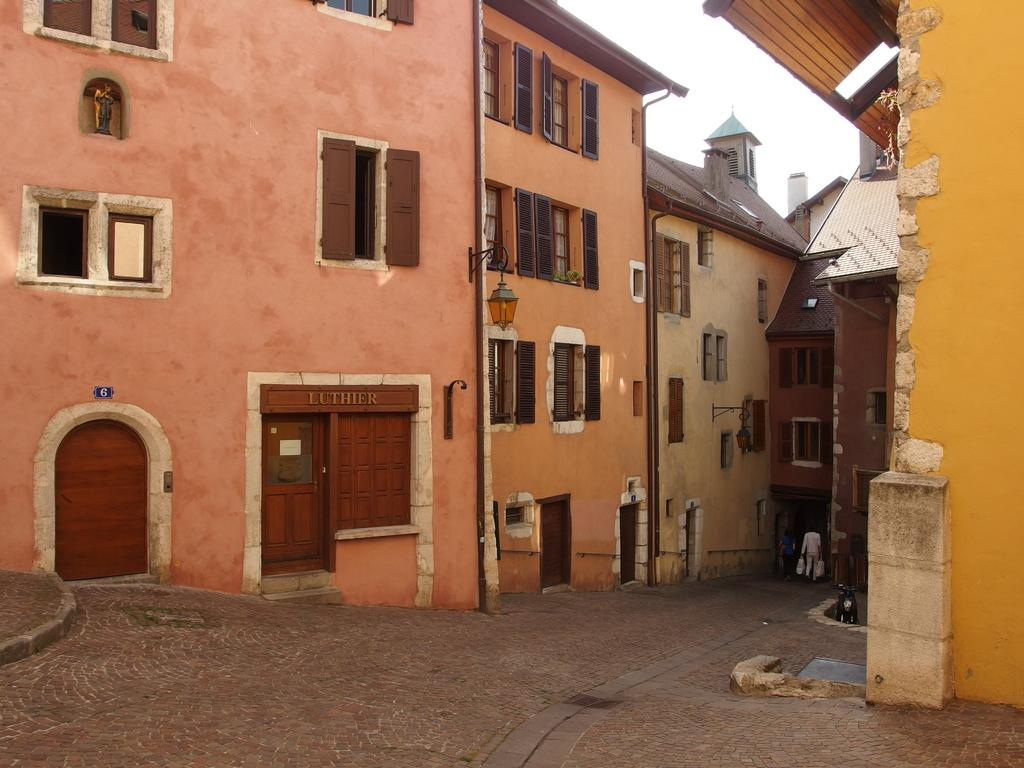What type of structures can be seen in the image? There are buildings in the image. What features can be observed on the buildings? There are windows and doors visible on the buildings. What mode of transportation is present in the image? There is a vehicle in the image. Who or what is on the road in the image? There are two persons on the road in the image. What part of the natural environment is visible in the image? The sky is visible in the image. Can you make an assumption about the time of day based on the image? The image might have been taken during the day, as there is no indication of darkness or artificial lighting. What type of plot is being developed by the dolls in the image? There are no dolls present in the image, so there is no plot being developed. What type of shade is being provided by the buildings in the image? The buildings in the image do not provide any shade, as they are not blocking the sun or providing a covered area. 